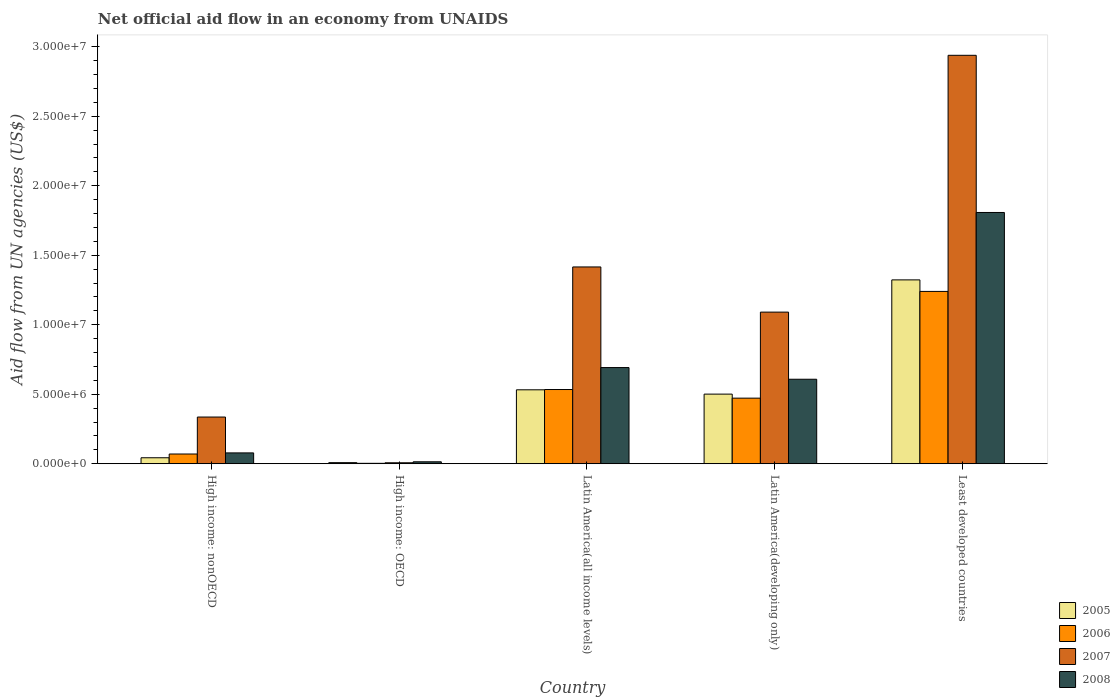How many bars are there on the 2nd tick from the left?
Your answer should be compact. 4. How many bars are there on the 2nd tick from the right?
Your answer should be compact. 4. What is the label of the 3rd group of bars from the left?
Make the answer very short. Latin America(all income levels). Across all countries, what is the maximum net official aid flow in 2008?
Your response must be concise. 1.81e+07. Across all countries, what is the minimum net official aid flow in 2008?
Provide a succinct answer. 1.40e+05. In which country was the net official aid flow in 2005 maximum?
Make the answer very short. Least developed countries. In which country was the net official aid flow in 2007 minimum?
Your answer should be very brief. High income: OECD. What is the total net official aid flow in 2007 in the graph?
Your response must be concise. 5.79e+07. What is the difference between the net official aid flow in 2005 in High income: nonOECD and that in Latin America(all income levels)?
Your answer should be compact. -4.89e+06. What is the difference between the net official aid flow in 2006 in Least developed countries and the net official aid flow in 2007 in High income: OECD?
Ensure brevity in your answer.  1.23e+07. What is the average net official aid flow in 2005 per country?
Keep it short and to the point. 4.81e+06. What is the difference between the net official aid flow of/in 2006 and net official aid flow of/in 2007 in Least developed countries?
Give a very brief answer. -1.70e+07. What is the ratio of the net official aid flow in 2008 in High income: OECD to that in Latin America(developing only)?
Ensure brevity in your answer.  0.02. Is the difference between the net official aid flow in 2006 in Latin America(all income levels) and Latin America(developing only) greater than the difference between the net official aid flow in 2007 in Latin America(all income levels) and Latin America(developing only)?
Your response must be concise. No. What is the difference between the highest and the second highest net official aid flow in 2006?
Give a very brief answer. 7.06e+06. What is the difference between the highest and the lowest net official aid flow in 2006?
Offer a terse response. 1.24e+07. In how many countries, is the net official aid flow in 2005 greater than the average net official aid flow in 2005 taken over all countries?
Provide a short and direct response. 3. What does the 2nd bar from the right in High income: OECD represents?
Provide a succinct answer. 2007. Is it the case that in every country, the sum of the net official aid flow in 2006 and net official aid flow in 2008 is greater than the net official aid flow in 2005?
Offer a terse response. Yes. How many countries are there in the graph?
Your response must be concise. 5. What is the difference between two consecutive major ticks on the Y-axis?
Your answer should be compact. 5.00e+06. Are the values on the major ticks of Y-axis written in scientific E-notation?
Provide a short and direct response. Yes. Where does the legend appear in the graph?
Make the answer very short. Bottom right. How are the legend labels stacked?
Give a very brief answer. Vertical. What is the title of the graph?
Offer a terse response. Net official aid flow in an economy from UNAIDS. What is the label or title of the Y-axis?
Your answer should be compact. Aid flow from UN agencies (US$). What is the Aid flow from UN agencies (US$) in 2006 in High income: nonOECD?
Ensure brevity in your answer.  7.00e+05. What is the Aid flow from UN agencies (US$) of 2007 in High income: nonOECD?
Provide a short and direct response. 3.36e+06. What is the Aid flow from UN agencies (US$) of 2008 in High income: nonOECD?
Ensure brevity in your answer.  7.80e+05. What is the Aid flow from UN agencies (US$) of 2005 in High income: OECD?
Provide a succinct answer. 8.00e+04. What is the Aid flow from UN agencies (US$) of 2008 in High income: OECD?
Provide a short and direct response. 1.40e+05. What is the Aid flow from UN agencies (US$) in 2005 in Latin America(all income levels)?
Provide a succinct answer. 5.32e+06. What is the Aid flow from UN agencies (US$) of 2006 in Latin America(all income levels)?
Your response must be concise. 5.34e+06. What is the Aid flow from UN agencies (US$) of 2007 in Latin America(all income levels)?
Offer a terse response. 1.42e+07. What is the Aid flow from UN agencies (US$) of 2008 in Latin America(all income levels)?
Your answer should be compact. 6.92e+06. What is the Aid flow from UN agencies (US$) in 2005 in Latin America(developing only)?
Give a very brief answer. 5.01e+06. What is the Aid flow from UN agencies (US$) of 2006 in Latin America(developing only)?
Ensure brevity in your answer.  4.72e+06. What is the Aid flow from UN agencies (US$) in 2007 in Latin America(developing only)?
Ensure brevity in your answer.  1.09e+07. What is the Aid flow from UN agencies (US$) in 2008 in Latin America(developing only)?
Make the answer very short. 6.08e+06. What is the Aid flow from UN agencies (US$) in 2005 in Least developed countries?
Make the answer very short. 1.32e+07. What is the Aid flow from UN agencies (US$) of 2006 in Least developed countries?
Provide a short and direct response. 1.24e+07. What is the Aid flow from UN agencies (US$) of 2007 in Least developed countries?
Your answer should be compact. 2.94e+07. What is the Aid flow from UN agencies (US$) of 2008 in Least developed countries?
Provide a succinct answer. 1.81e+07. Across all countries, what is the maximum Aid flow from UN agencies (US$) in 2005?
Ensure brevity in your answer.  1.32e+07. Across all countries, what is the maximum Aid flow from UN agencies (US$) of 2006?
Make the answer very short. 1.24e+07. Across all countries, what is the maximum Aid flow from UN agencies (US$) of 2007?
Give a very brief answer. 2.94e+07. Across all countries, what is the maximum Aid flow from UN agencies (US$) of 2008?
Make the answer very short. 1.81e+07. Across all countries, what is the minimum Aid flow from UN agencies (US$) in 2008?
Provide a succinct answer. 1.40e+05. What is the total Aid flow from UN agencies (US$) of 2005 in the graph?
Provide a succinct answer. 2.41e+07. What is the total Aid flow from UN agencies (US$) in 2006 in the graph?
Give a very brief answer. 2.32e+07. What is the total Aid flow from UN agencies (US$) of 2007 in the graph?
Provide a short and direct response. 5.79e+07. What is the total Aid flow from UN agencies (US$) of 2008 in the graph?
Make the answer very short. 3.20e+07. What is the difference between the Aid flow from UN agencies (US$) of 2006 in High income: nonOECD and that in High income: OECD?
Give a very brief answer. 6.70e+05. What is the difference between the Aid flow from UN agencies (US$) of 2007 in High income: nonOECD and that in High income: OECD?
Your answer should be very brief. 3.29e+06. What is the difference between the Aid flow from UN agencies (US$) of 2008 in High income: nonOECD and that in High income: OECD?
Offer a terse response. 6.40e+05. What is the difference between the Aid flow from UN agencies (US$) in 2005 in High income: nonOECD and that in Latin America(all income levels)?
Provide a succinct answer. -4.89e+06. What is the difference between the Aid flow from UN agencies (US$) of 2006 in High income: nonOECD and that in Latin America(all income levels)?
Ensure brevity in your answer.  -4.64e+06. What is the difference between the Aid flow from UN agencies (US$) in 2007 in High income: nonOECD and that in Latin America(all income levels)?
Offer a terse response. -1.08e+07. What is the difference between the Aid flow from UN agencies (US$) of 2008 in High income: nonOECD and that in Latin America(all income levels)?
Keep it short and to the point. -6.14e+06. What is the difference between the Aid flow from UN agencies (US$) in 2005 in High income: nonOECD and that in Latin America(developing only)?
Offer a very short reply. -4.58e+06. What is the difference between the Aid flow from UN agencies (US$) of 2006 in High income: nonOECD and that in Latin America(developing only)?
Provide a short and direct response. -4.02e+06. What is the difference between the Aid flow from UN agencies (US$) of 2007 in High income: nonOECD and that in Latin America(developing only)?
Offer a terse response. -7.55e+06. What is the difference between the Aid flow from UN agencies (US$) of 2008 in High income: nonOECD and that in Latin America(developing only)?
Offer a terse response. -5.30e+06. What is the difference between the Aid flow from UN agencies (US$) of 2005 in High income: nonOECD and that in Least developed countries?
Provide a succinct answer. -1.28e+07. What is the difference between the Aid flow from UN agencies (US$) of 2006 in High income: nonOECD and that in Least developed countries?
Keep it short and to the point. -1.17e+07. What is the difference between the Aid flow from UN agencies (US$) of 2007 in High income: nonOECD and that in Least developed countries?
Your answer should be very brief. -2.60e+07. What is the difference between the Aid flow from UN agencies (US$) in 2008 in High income: nonOECD and that in Least developed countries?
Your answer should be compact. -1.73e+07. What is the difference between the Aid flow from UN agencies (US$) of 2005 in High income: OECD and that in Latin America(all income levels)?
Your response must be concise. -5.24e+06. What is the difference between the Aid flow from UN agencies (US$) in 2006 in High income: OECD and that in Latin America(all income levels)?
Ensure brevity in your answer.  -5.31e+06. What is the difference between the Aid flow from UN agencies (US$) of 2007 in High income: OECD and that in Latin America(all income levels)?
Your answer should be compact. -1.41e+07. What is the difference between the Aid flow from UN agencies (US$) in 2008 in High income: OECD and that in Latin America(all income levels)?
Provide a succinct answer. -6.78e+06. What is the difference between the Aid flow from UN agencies (US$) of 2005 in High income: OECD and that in Latin America(developing only)?
Provide a succinct answer. -4.93e+06. What is the difference between the Aid flow from UN agencies (US$) in 2006 in High income: OECD and that in Latin America(developing only)?
Ensure brevity in your answer.  -4.69e+06. What is the difference between the Aid flow from UN agencies (US$) in 2007 in High income: OECD and that in Latin America(developing only)?
Offer a terse response. -1.08e+07. What is the difference between the Aid flow from UN agencies (US$) in 2008 in High income: OECD and that in Latin America(developing only)?
Keep it short and to the point. -5.94e+06. What is the difference between the Aid flow from UN agencies (US$) of 2005 in High income: OECD and that in Least developed countries?
Keep it short and to the point. -1.32e+07. What is the difference between the Aid flow from UN agencies (US$) in 2006 in High income: OECD and that in Least developed countries?
Make the answer very short. -1.24e+07. What is the difference between the Aid flow from UN agencies (US$) in 2007 in High income: OECD and that in Least developed countries?
Offer a terse response. -2.93e+07. What is the difference between the Aid flow from UN agencies (US$) of 2008 in High income: OECD and that in Least developed countries?
Provide a short and direct response. -1.79e+07. What is the difference between the Aid flow from UN agencies (US$) in 2005 in Latin America(all income levels) and that in Latin America(developing only)?
Ensure brevity in your answer.  3.10e+05. What is the difference between the Aid flow from UN agencies (US$) of 2006 in Latin America(all income levels) and that in Latin America(developing only)?
Make the answer very short. 6.20e+05. What is the difference between the Aid flow from UN agencies (US$) of 2007 in Latin America(all income levels) and that in Latin America(developing only)?
Keep it short and to the point. 3.25e+06. What is the difference between the Aid flow from UN agencies (US$) of 2008 in Latin America(all income levels) and that in Latin America(developing only)?
Make the answer very short. 8.40e+05. What is the difference between the Aid flow from UN agencies (US$) of 2005 in Latin America(all income levels) and that in Least developed countries?
Give a very brief answer. -7.91e+06. What is the difference between the Aid flow from UN agencies (US$) in 2006 in Latin America(all income levels) and that in Least developed countries?
Offer a very short reply. -7.06e+06. What is the difference between the Aid flow from UN agencies (US$) in 2007 in Latin America(all income levels) and that in Least developed countries?
Offer a terse response. -1.52e+07. What is the difference between the Aid flow from UN agencies (US$) of 2008 in Latin America(all income levels) and that in Least developed countries?
Your response must be concise. -1.12e+07. What is the difference between the Aid flow from UN agencies (US$) of 2005 in Latin America(developing only) and that in Least developed countries?
Offer a terse response. -8.22e+06. What is the difference between the Aid flow from UN agencies (US$) in 2006 in Latin America(developing only) and that in Least developed countries?
Offer a terse response. -7.68e+06. What is the difference between the Aid flow from UN agencies (US$) of 2007 in Latin America(developing only) and that in Least developed countries?
Provide a succinct answer. -1.85e+07. What is the difference between the Aid flow from UN agencies (US$) of 2008 in Latin America(developing only) and that in Least developed countries?
Your answer should be compact. -1.20e+07. What is the difference between the Aid flow from UN agencies (US$) of 2005 in High income: nonOECD and the Aid flow from UN agencies (US$) of 2008 in High income: OECD?
Provide a short and direct response. 2.90e+05. What is the difference between the Aid flow from UN agencies (US$) of 2006 in High income: nonOECD and the Aid flow from UN agencies (US$) of 2007 in High income: OECD?
Your answer should be compact. 6.30e+05. What is the difference between the Aid flow from UN agencies (US$) in 2006 in High income: nonOECD and the Aid flow from UN agencies (US$) in 2008 in High income: OECD?
Make the answer very short. 5.60e+05. What is the difference between the Aid flow from UN agencies (US$) in 2007 in High income: nonOECD and the Aid flow from UN agencies (US$) in 2008 in High income: OECD?
Offer a terse response. 3.22e+06. What is the difference between the Aid flow from UN agencies (US$) of 2005 in High income: nonOECD and the Aid flow from UN agencies (US$) of 2006 in Latin America(all income levels)?
Provide a short and direct response. -4.91e+06. What is the difference between the Aid flow from UN agencies (US$) of 2005 in High income: nonOECD and the Aid flow from UN agencies (US$) of 2007 in Latin America(all income levels)?
Your response must be concise. -1.37e+07. What is the difference between the Aid flow from UN agencies (US$) of 2005 in High income: nonOECD and the Aid flow from UN agencies (US$) of 2008 in Latin America(all income levels)?
Provide a short and direct response. -6.49e+06. What is the difference between the Aid flow from UN agencies (US$) of 2006 in High income: nonOECD and the Aid flow from UN agencies (US$) of 2007 in Latin America(all income levels)?
Offer a terse response. -1.35e+07. What is the difference between the Aid flow from UN agencies (US$) of 2006 in High income: nonOECD and the Aid flow from UN agencies (US$) of 2008 in Latin America(all income levels)?
Give a very brief answer. -6.22e+06. What is the difference between the Aid flow from UN agencies (US$) of 2007 in High income: nonOECD and the Aid flow from UN agencies (US$) of 2008 in Latin America(all income levels)?
Provide a short and direct response. -3.56e+06. What is the difference between the Aid flow from UN agencies (US$) in 2005 in High income: nonOECD and the Aid flow from UN agencies (US$) in 2006 in Latin America(developing only)?
Give a very brief answer. -4.29e+06. What is the difference between the Aid flow from UN agencies (US$) in 2005 in High income: nonOECD and the Aid flow from UN agencies (US$) in 2007 in Latin America(developing only)?
Your answer should be very brief. -1.05e+07. What is the difference between the Aid flow from UN agencies (US$) in 2005 in High income: nonOECD and the Aid flow from UN agencies (US$) in 2008 in Latin America(developing only)?
Your answer should be compact. -5.65e+06. What is the difference between the Aid flow from UN agencies (US$) of 2006 in High income: nonOECD and the Aid flow from UN agencies (US$) of 2007 in Latin America(developing only)?
Offer a very short reply. -1.02e+07. What is the difference between the Aid flow from UN agencies (US$) of 2006 in High income: nonOECD and the Aid flow from UN agencies (US$) of 2008 in Latin America(developing only)?
Your answer should be compact. -5.38e+06. What is the difference between the Aid flow from UN agencies (US$) of 2007 in High income: nonOECD and the Aid flow from UN agencies (US$) of 2008 in Latin America(developing only)?
Offer a terse response. -2.72e+06. What is the difference between the Aid flow from UN agencies (US$) of 2005 in High income: nonOECD and the Aid flow from UN agencies (US$) of 2006 in Least developed countries?
Offer a terse response. -1.20e+07. What is the difference between the Aid flow from UN agencies (US$) of 2005 in High income: nonOECD and the Aid flow from UN agencies (US$) of 2007 in Least developed countries?
Your answer should be compact. -2.90e+07. What is the difference between the Aid flow from UN agencies (US$) in 2005 in High income: nonOECD and the Aid flow from UN agencies (US$) in 2008 in Least developed countries?
Give a very brief answer. -1.76e+07. What is the difference between the Aid flow from UN agencies (US$) of 2006 in High income: nonOECD and the Aid flow from UN agencies (US$) of 2007 in Least developed countries?
Keep it short and to the point. -2.87e+07. What is the difference between the Aid flow from UN agencies (US$) in 2006 in High income: nonOECD and the Aid flow from UN agencies (US$) in 2008 in Least developed countries?
Offer a terse response. -1.74e+07. What is the difference between the Aid flow from UN agencies (US$) of 2007 in High income: nonOECD and the Aid flow from UN agencies (US$) of 2008 in Least developed countries?
Offer a terse response. -1.47e+07. What is the difference between the Aid flow from UN agencies (US$) in 2005 in High income: OECD and the Aid flow from UN agencies (US$) in 2006 in Latin America(all income levels)?
Your answer should be compact. -5.26e+06. What is the difference between the Aid flow from UN agencies (US$) in 2005 in High income: OECD and the Aid flow from UN agencies (US$) in 2007 in Latin America(all income levels)?
Your answer should be very brief. -1.41e+07. What is the difference between the Aid flow from UN agencies (US$) in 2005 in High income: OECD and the Aid flow from UN agencies (US$) in 2008 in Latin America(all income levels)?
Give a very brief answer. -6.84e+06. What is the difference between the Aid flow from UN agencies (US$) in 2006 in High income: OECD and the Aid flow from UN agencies (US$) in 2007 in Latin America(all income levels)?
Give a very brief answer. -1.41e+07. What is the difference between the Aid flow from UN agencies (US$) in 2006 in High income: OECD and the Aid flow from UN agencies (US$) in 2008 in Latin America(all income levels)?
Your answer should be compact. -6.89e+06. What is the difference between the Aid flow from UN agencies (US$) of 2007 in High income: OECD and the Aid flow from UN agencies (US$) of 2008 in Latin America(all income levels)?
Offer a very short reply. -6.85e+06. What is the difference between the Aid flow from UN agencies (US$) of 2005 in High income: OECD and the Aid flow from UN agencies (US$) of 2006 in Latin America(developing only)?
Make the answer very short. -4.64e+06. What is the difference between the Aid flow from UN agencies (US$) of 2005 in High income: OECD and the Aid flow from UN agencies (US$) of 2007 in Latin America(developing only)?
Give a very brief answer. -1.08e+07. What is the difference between the Aid flow from UN agencies (US$) in 2005 in High income: OECD and the Aid flow from UN agencies (US$) in 2008 in Latin America(developing only)?
Offer a very short reply. -6.00e+06. What is the difference between the Aid flow from UN agencies (US$) of 2006 in High income: OECD and the Aid flow from UN agencies (US$) of 2007 in Latin America(developing only)?
Make the answer very short. -1.09e+07. What is the difference between the Aid flow from UN agencies (US$) of 2006 in High income: OECD and the Aid flow from UN agencies (US$) of 2008 in Latin America(developing only)?
Provide a short and direct response. -6.05e+06. What is the difference between the Aid flow from UN agencies (US$) of 2007 in High income: OECD and the Aid flow from UN agencies (US$) of 2008 in Latin America(developing only)?
Ensure brevity in your answer.  -6.01e+06. What is the difference between the Aid flow from UN agencies (US$) in 2005 in High income: OECD and the Aid flow from UN agencies (US$) in 2006 in Least developed countries?
Your answer should be very brief. -1.23e+07. What is the difference between the Aid flow from UN agencies (US$) of 2005 in High income: OECD and the Aid flow from UN agencies (US$) of 2007 in Least developed countries?
Make the answer very short. -2.93e+07. What is the difference between the Aid flow from UN agencies (US$) of 2005 in High income: OECD and the Aid flow from UN agencies (US$) of 2008 in Least developed countries?
Offer a terse response. -1.80e+07. What is the difference between the Aid flow from UN agencies (US$) of 2006 in High income: OECD and the Aid flow from UN agencies (US$) of 2007 in Least developed countries?
Ensure brevity in your answer.  -2.94e+07. What is the difference between the Aid flow from UN agencies (US$) in 2006 in High income: OECD and the Aid flow from UN agencies (US$) in 2008 in Least developed countries?
Offer a very short reply. -1.80e+07. What is the difference between the Aid flow from UN agencies (US$) in 2007 in High income: OECD and the Aid flow from UN agencies (US$) in 2008 in Least developed countries?
Provide a succinct answer. -1.80e+07. What is the difference between the Aid flow from UN agencies (US$) of 2005 in Latin America(all income levels) and the Aid flow from UN agencies (US$) of 2007 in Latin America(developing only)?
Keep it short and to the point. -5.59e+06. What is the difference between the Aid flow from UN agencies (US$) of 2005 in Latin America(all income levels) and the Aid flow from UN agencies (US$) of 2008 in Latin America(developing only)?
Your answer should be very brief. -7.60e+05. What is the difference between the Aid flow from UN agencies (US$) of 2006 in Latin America(all income levels) and the Aid flow from UN agencies (US$) of 2007 in Latin America(developing only)?
Your response must be concise. -5.57e+06. What is the difference between the Aid flow from UN agencies (US$) of 2006 in Latin America(all income levels) and the Aid flow from UN agencies (US$) of 2008 in Latin America(developing only)?
Ensure brevity in your answer.  -7.40e+05. What is the difference between the Aid flow from UN agencies (US$) in 2007 in Latin America(all income levels) and the Aid flow from UN agencies (US$) in 2008 in Latin America(developing only)?
Give a very brief answer. 8.08e+06. What is the difference between the Aid flow from UN agencies (US$) in 2005 in Latin America(all income levels) and the Aid flow from UN agencies (US$) in 2006 in Least developed countries?
Give a very brief answer. -7.08e+06. What is the difference between the Aid flow from UN agencies (US$) of 2005 in Latin America(all income levels) and the Aid flow from UN agencies (US$) of 2007 in Least developed countries?
Ensure brevity in your answer.  -2.41e+07. What is the difference between the Aid flow from UN agencies (US$) in 2005 in Latin America(all income levels) and the Aid flow from UN agencies (US$) in 2008 in Least developed countries?
Provide a short and direct response. -1.28e+07. What is the difference between the Aid flow from UN agencies (US$) in 2006 in Latin America(all income levels) and the Aid flow from UN agencies (US$) in 2007 in Least developed countries?
Provide a succinct answer. -2.40e+07. What is the difference between the Aid flow from UN agencies (US$) in 2006 in Latin America(all income levels) and the Aid flow from UN agencies (US$) in 2008 in Least developed countries?
Your answer should be very brief. -1.27e+07. What is the difference between the Aid flow from UN agencies (US$) of 2007 in Latin America(all income levels) and the Aid flow from UN agencies (US$) of 2008 in Least developed countries?
Keep it short and to the point. -3.92e+06. What is the difference between the Aid flow from UN agencies (US$) of 2005 in Latin America(developing only) and the Aid flow from UN agencies (US$) of 2006 in Least developed countries?
Keep it short and to the point. -7.39e+06. What is the difference between the Aid flow from UN agencies (US$) of 2005 in Latin America(developing only) and the Aid flow from UN agencies (US$) of 2007 in Least developed countries?
Your answer should be compact. -2.44e+07. What is the difference between the Aid flow from UN agencies (US$) of 2005 in Latin America(developing only) and the Aid flow from UN agencies (US$) of 2008 in Least developed countries?
Your response must be concise. -1.31e+07. What is the difference between the Aid flow from UN agencies (US$) in 2006 in Latin America(developing only) and the Aid flow from UN agencies (US$) in 2007 in Least developed countries?
Your response must be concise. -2.47e+07. What is the difference between the Aid flow from UN agencies (US$) of 2006 in Latin America(developing only) and the Aid flow from UN agencies (US$) of 2008 in Least developed countries?
Your answer should be very brief. -1.34e+07. What is the difference between the Aid flow from UN agencies (US$) of 2007 in Latin America(developing only) and the Aid flow from UN agencies (US$) of 2008 in Least developed countries?
Give a very brief answer. -7.17e+06. What is the average Aid flow from UN agencies (US$) of 2005 per country?
Make the answer very short. 4.81e+06. What is the average Aid flow from UN agencies (US$) in 2006 per country?
Your answer should be compact. 4.64e+06. What is the average Aid flow from UN agencies (US$) in 2007 per country?
Keep it short and to the point. 1.16e+07. What is the average Aid flow from UN agencies (US$) of 2008 per country?
Your response must be concise. 6.40e+06. What is the difference between the Aid flow from UN agencies (US$) of 2005 and Aid flow from UN agencies (US$) of 2006 in High income: nonOECD?
Provide a short and direct response. -2.70e+05. What is the difference between the Aid flow from UN agencies (US$) in 2005 and Aid flow from UN agencies (US$) in 2007 in High income: nonOECD?
Keep it short and to the point. -2.93e+06. What is the difference between the Aid flow from UN agencies (US$) of 2005 and Aid flow from UN agencies (US$) of 2008 in High income: nonOECD?
Offer a very short reply. -3.50e+05. What is the difference between the Aid flow from UN agencies (US$) in 2006 and Aid flow from UN agencies (US$) in 2007 in High income: nonOECD?
Offer a terse response. -2.66e+06. What is the difference between the Aid flow from UN agencies (US$) in 2006 and Aid flow from UN agencies (US$) in 2008 in High income: nonOECD?
Your response must be concise. -8.00e+04. What is the difference between the Aid flow from UN agencies (US$) of 2007 and Aid flow from UN agencies (US$) of 2008 in High income: nonOECD?
Your answer should be very brief. 2.58e+06. What is the difference between the Aid flow from UN agencies (US$) in 2005 and Aid flow from UN agencies (US$) in 2006 in High income: OECD?
Ensure brevity in your answer.  5.00e+04. What is the difference between the Aid flow from UN agencies (US$) of 2005 and Aid flow from UN agencies (US$) of 2008 in High income: OECD?
Offer a terse response. -6.00e+04. What is the difference between the Aid flow from UN agencies (US$) in 2005 and Aid flow from UN agencies (US$) in 2006 in Latin America(all income levels)?
Keep it short and to the point. -2.00e+04. What is the difference between the Aid flow from UN agencies (US$) of 2005 and Aid flow from UN agencies (US$) of 2007 in Latin America(all income levels)?
Provide a short and direct response. -8.84e+06. What is the difference between the Aid flow from UN agencies (US$) in 2005 and Aid flow from UN agencies (US$) in 2008 in Latin America(all income levels)?
Make the answer very short. -1.60e+06. What is the difference between the Aid flow from UN agencies (US$) of 2006 and Aid flow from UN agencies (US$) of 2007 in Latin America(all income levels)?
Keep it short and to the point. -8.82e+06. What is the difference between the Aid flow from UN agencies (US$) of 2006 and Aid flow from UN agencies (US$) of 2008 in Latin America(all income levels)?
Provide a short and direct response. -1.58e+06. What is the difference between the Aid flow from UN agencies (US$) in 2007 and Aid flow from UN agencies (US$) in 2008 in Latin America(all income levels)?
Offer a very short reply. 7.24e+06. What is the difference between the Aid flow from UN agencies (US$) of 2005 and Aid flow from UN agencies (US$) of 2006 in Latin America(developing only)?
Your answer should be very brief. 2.90e+05. What is the difference between the Aid flow from UN agencies (US$) in 2005 and Aid flow from UN agencies (US$) in 2007 in Latin America(developing only)?
Keep it short and to the point. -5.90e+06. What is the difference between the Aid flow from UN agencies (US$) in 2005 and Aid flow from UN agencies (US$) in 2008 in Latin America(developing only)?
Your answer should be very brief. -1.07e+06. What is the difference between the Aid flow from UN agencies (US$) in 2006 and Aid flow from UN agencies (US$) in 2007 in Latin America(developing only)?
Provide a short and direct response. -6.19e+06. What is the difference between the Aid flow from UN agencies (US$) of 2006 and Aid flow from UN agencies (US$) of 2008 in Latin America(developing only)?
Keep it short and to the point. -1.36e+06. What is the difference between the Aid flow from UN agencies (US$) in 2007 and Aid flow from UN agencies (US$) in 2008 in Latin America(developing only)?
Give a very brief answer. 4.83e+06. What is the difference between the Aid flow from UN agencies (US$) in 2005 and Aid flow from UN agencies (US$) in 2006 in Least developed countries?
Give a very brief answer. 8.30e+05. What is the difference between the Aid flow from UN agencies (US$) in 2005 and Aid flow from UN agencies (US$) in 2007 in Least developed countries?
Provide a short and direct response. -1.62e+07. What is the difference between the Aid flow from UN agencies (US$) of 2005 and Aid flow from UN agencies (US$) of 2008 in Least developed countries?
Make the answer very short. -4.85e+06. What is the difference between the Aid flow from UN agencies (US$) in 2006 and Aid flow from UN agencies (US$) in 2007 in Least developed countries?
Your response must be concise. -1.70e+07. What is the difference between the Aid flow from UN agencies (US$) of 2006 and Aid flow from UN agencies (US$) of 2008 in Least developed countries?
Your answer should be very brief. -5.68e+06. What is the difference between the Aid flow from UN agencies (US$) of 2007 and Aid flow from UN agencies (US$) of 2008 in Least developed countries?
Keep it short and to the point. 1.13e+07. What is the ratio of the Aid flow from UN agencies (US$) in 2005 in High income: nonOECD to that in High income: OECD?
Make the answer very short. 5.38. What is the ratio of the Aid flow from UN agencies (US$) in 2006 in High income: nonOECD to that in High income: OECD?
Make the answer very short. 23.33. What is the ratio of the Aid flow from UN agencies (US$) in 2008 in High income: nonOECD to that in High income: OECD?
Offer a terse response. 5.57. What is the ratio of the Aid flow from UN agencies (US$) of 2005 in High income: nonOECD to that in Latin America(all income levels)?
Your answer should be compact. 0.08. What is the ratio of the Aid flow from UN agencies (US$) in 2006 in High income: nonOECD to that in Latin America(all income levels)?
Ensure brevity in your answer.  0.13. What is the ratio of the Aid flow from UN agencies (US$) of 2007 in High income: nonOECD to that in Latin America(all income levels)?
Keep it short and to the point. 0.24. What is the ratio of the Aid flow from UN agencies (US$) of 2008 in High income: nonOECD to that in Latin America(all income levels)?
Make the answer very short. 0.11. What is the ratio of the Aid flow from UN agencies (US$) in 2005 in High income: nonOECD to that in Latin America(developing only)?
Your answer should be compact. 0.09. What is the ratio of the Aid flow from UN agencies (US$) in 2006 in High income: nonOECD to that in Latin America(developing only)?
Offer a very short reply. 0.15. What is the ratio of the Aid flow from UN agencies (US$) in 2007 in High income: nonOECD to that in Latin America(developing only)?
Your answer should be compact. 0.31. What is the ratio of the Aid flow from UN agencies (US$) in 2008 in High income: nonOECD to that in Latin America(developing only)?
Offer a very short reply. 0.13. What is the ratio of the Aid flow from UN agencies (US$) of 2005 in High income: nonOECD to that in Least developed countries?
Make the answer very short. 0.03. What is the ratio of the Aid flow from UN agencies (US$) in 2006 in High income: nonOECD to that in Least developed countries?
Your response must be concise. 0.06. What is the ratio of the Aid flow from UN agencies (US$) of 2007 in High income: nonOECD to that in Least developed countries?
Ensure brevity in your answer.  0.11. What is the ratio of the Aid flow from UN agencies (US$) of 2008 in High income: nonOECD to that in Least developed countries?
Provide a short and direct response. 0.04. What is the ratio of the Aid flow from UN agencies (US$) of 2005 in High income: OECD to that in Latin America(all income levels)?
Keep it short and to the point. 0.01. What is the ratio of the Aid flow from UN agencies (US$) of 2006 in High income: OECD to that in Latin America(all income levels)?
Offer a very short reply. 0.01. What is the ratio of the Aid flow from UN agencies (US$) of 2007 in High income: OECD to that in Latin America(all income levels)?
Make the answer very short. 0. What is the ratio of the Aid flow from UN agencies (US$) in 2008 in High income: OECD to that in Latin America(all income levels)?
Offer a very short reply. 0.02. What is the ratio of the Aid flow from UN agencies (US$) of 2005 in High income: OECD to that in Latin America(developing only)?
Give a very brief answer. 0.02. What is the ratio of the Aid flow from UN agencies (US$) in 2006 in High income: OECD to that in Latin America(developing only)?
Make the answer very short. 0.01. What is the ratio of the Aid flow from UN agencies (US$) of 2007 in High income: OECD to that in Latin America(developing only)?
Ensure brevity in your answer.  0.01. What is the ratio of the Aid flow from UN agencies (US$) in 2008 in High income: OECD to that in Latin America(developing only)?
Offer a very short reply. 0.02. What is the ratio of the Aid flow from UN agencies (US$) of 2005 in High income: OECD to that in Least developed countries?
Provide a short and direct response. 0.01. What is the ratio of the Aid flow from UN agencies (US$) in 2006 in High income: OECD to that in Least developed countries?
Your answer should be very brief. 0. What is the ratio of the Aid flow from UN agencies (US$) of 2007 in High income: OECD to that in Least developed countries?
Offer a very short reply. 0. What is the ratio of the Aid flow from UN agencies (US$) in 2008 in High income: OECD to that in Least developed countries?
Ensure brevity in your answer.  0.01. What is the ratio of the Aid flow from UN agencies (US$) in 2005 in Latin America(all income levels) to that in Latin America(developing only)?
Provide a short and direct response. 1.06. What is the ratio of the Aid flow from UN agencies (US$) in 2006 in Latin America(all income levels) to that in Latin America(developing only)?
Your answer should be very brief. 1.13. What is the ratio of the Aid flow from UN agencies (US$) in 2007 in Latin America(all income levels) to that in Latin America(developing only)?
Make the answer very short. 1.3. What is the ratio of the Aid flow from UN agencies (US$) of 2008 in Latin America(all income levels) to that in Latin America(developing only)?
Provide a short and direct response. 1.14. What is the ratio of the Aid flow from UN agencies (US$) in 2005 in Latin America(all income levels) to that in Least developed countries?
Your response must be concise. 0.4. What is the ratio of the Aid flow from UN agencies (US$) in 2006 in Latin America(all income levels) to that in Least developed countries?
Your answer should be very brief. 0.43. What is the ratio of the Aid flow from UN agencies (US$) of 2007 in Latin America(all income levels) to that in Least developed countries?
Your answer should be very brief. 0.48. What is the ratio of the Aid flow from UN agencies (US$) of 2008 in Latin America(all income levels) to that in Least developed countries?
Your answer should be compact. 0.38. What is the ratio of the Aid flow from UN agencies (US$) in 2005 in Latin America(developing only) to that in Least developed countries?
Your answer should be very brief. 0.38. What is the ratio of the Aid flow from UN agencies (US$) in 2006 in Latin America(developing only) to that in Least developed countries?
Your response must be concise. 0.38. What is the ratio of the Aid flow from UN agencies (US$) of 2007 in Latin America(developing only) to that in Least developed countries?
Give a very brief answer. 0.37. What is the ratio of the Aid flow from UN agencies (US$) in 2008 in Latin America(developing only) to that in Least developed countries?
Your response must be concise. 0.34. What is the difference between the highest and the second highest Aid flow from UN agencies (US$) in 2005?
Provide a succinct answer. 7.91e+06. What is the difference between the highest and the second highest Aid flow from UN agencies (US$) in 2006?
Your answer should be very brief. 7.06e+06. What is the difference between the highest and the second highest Aid flow from UN agencies (US$) of 2007?
Keep it short and to the point. 1.52e+07. What is the difference between the highest and the second highest Aid flow from UN agencies (US$) in 2008?
Your response must be concise. 1.12e+07. What is the difference between the highest and the lowest Aid flow from UN agencies (US$) in 2005?
Keep it short and to the point. 1.32e+07. What is the difference between the highest and the lowest Aid flow from UN agencies (US$) of 2006?
Offer a very short reply. 1.24e+07. What is the difference between the highest and the lowest Aid flow from UN agencies (US$) of 2007?
Offer a very short reply. 2.93e+07. What is the difference between the highest and the lowest Aid flow from UN agencies (US$) in 2008?
Give a very brief answer. 1.79e+07. 